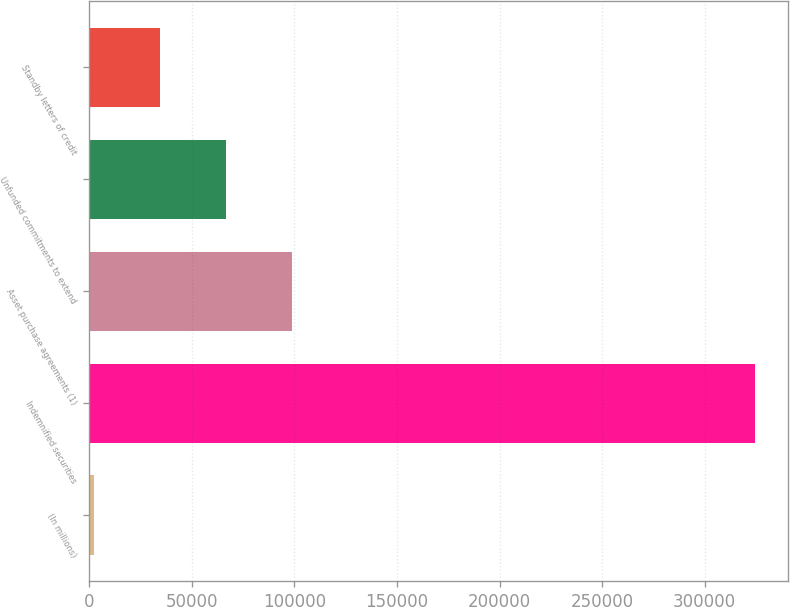Convert chart to OTSL. <chart><loc_0><loc_0><loc_500><loc_500><bar_chart><fcel>(In millions)<fcel>Indemnified securities<fcel>Asset purchase agreements (1)<fcel>Unfunded commitments to extend<fcel>Standby letters of credit<nl><fcel>2008<fcel>324590<fcel>98782.6<fcel>66524.4<fcel>34266.2<nl></chart> 